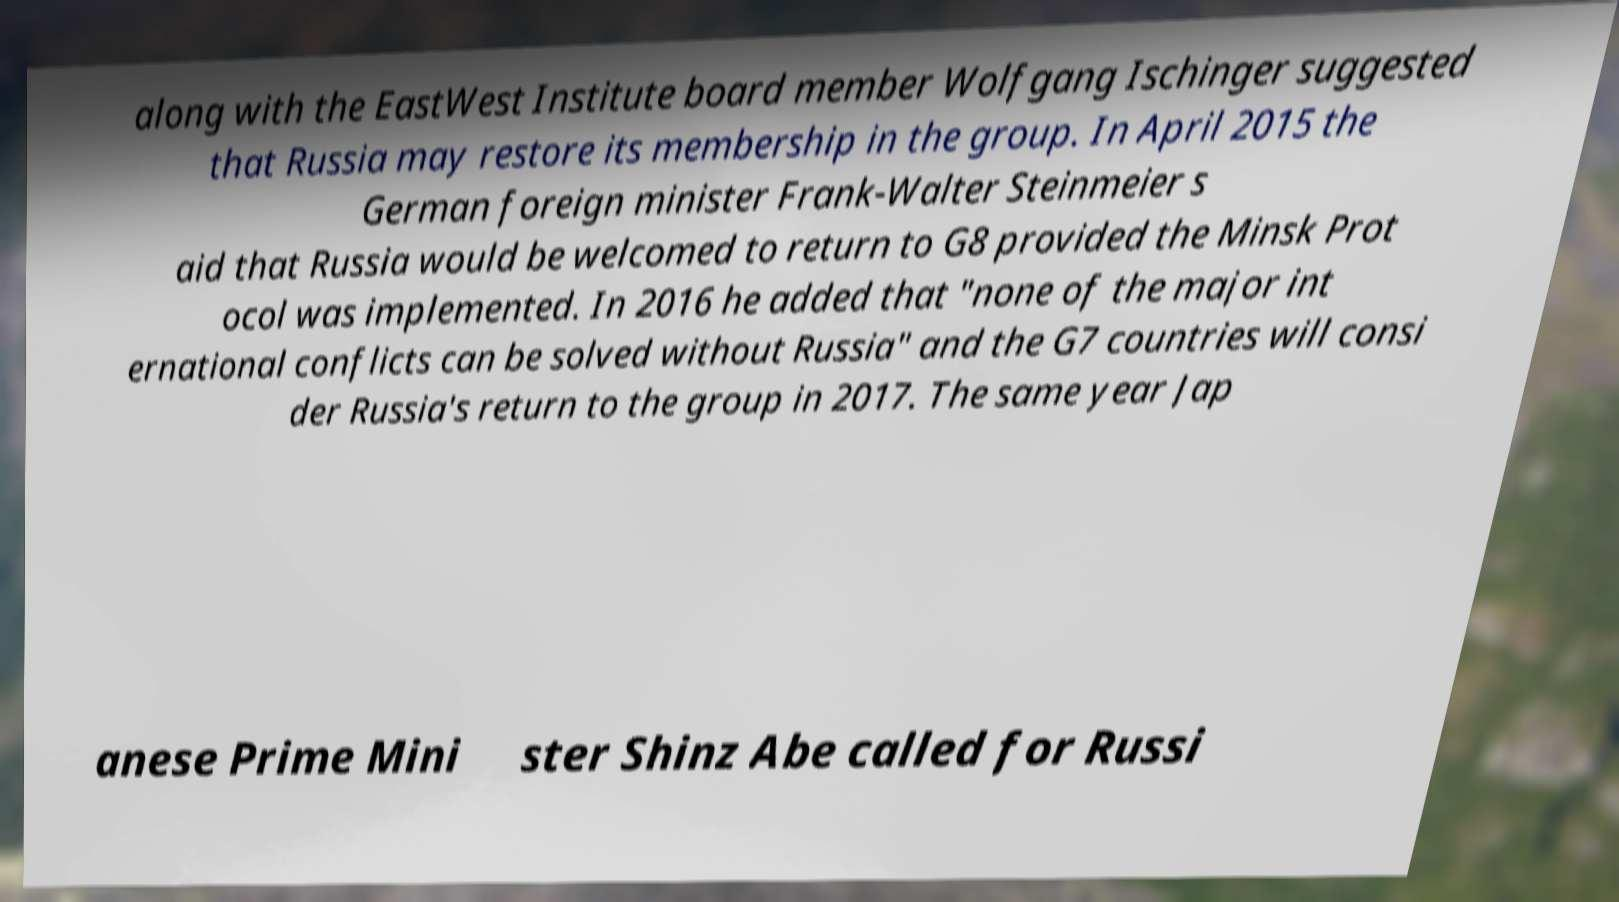I need the written content from this picture converted into text. Can you do that? along with the EastWest Institute board member Wolfgang Ischinger suggested that Russia may restore its membership in the group. In April 2015 the German foreign minister Frank-Walter Steinmeier s aid that Russia would be welcomed to return to G8 provided the Minsk Prot ocol was implemented. In 2016 he added that "none of the major int ernational conflicts can be solved without Russia" and the G7 countries will consi der Russia's return to the group in 2017. The same year Jap anese Prime Mini ster Shinz Abe called for Russi 